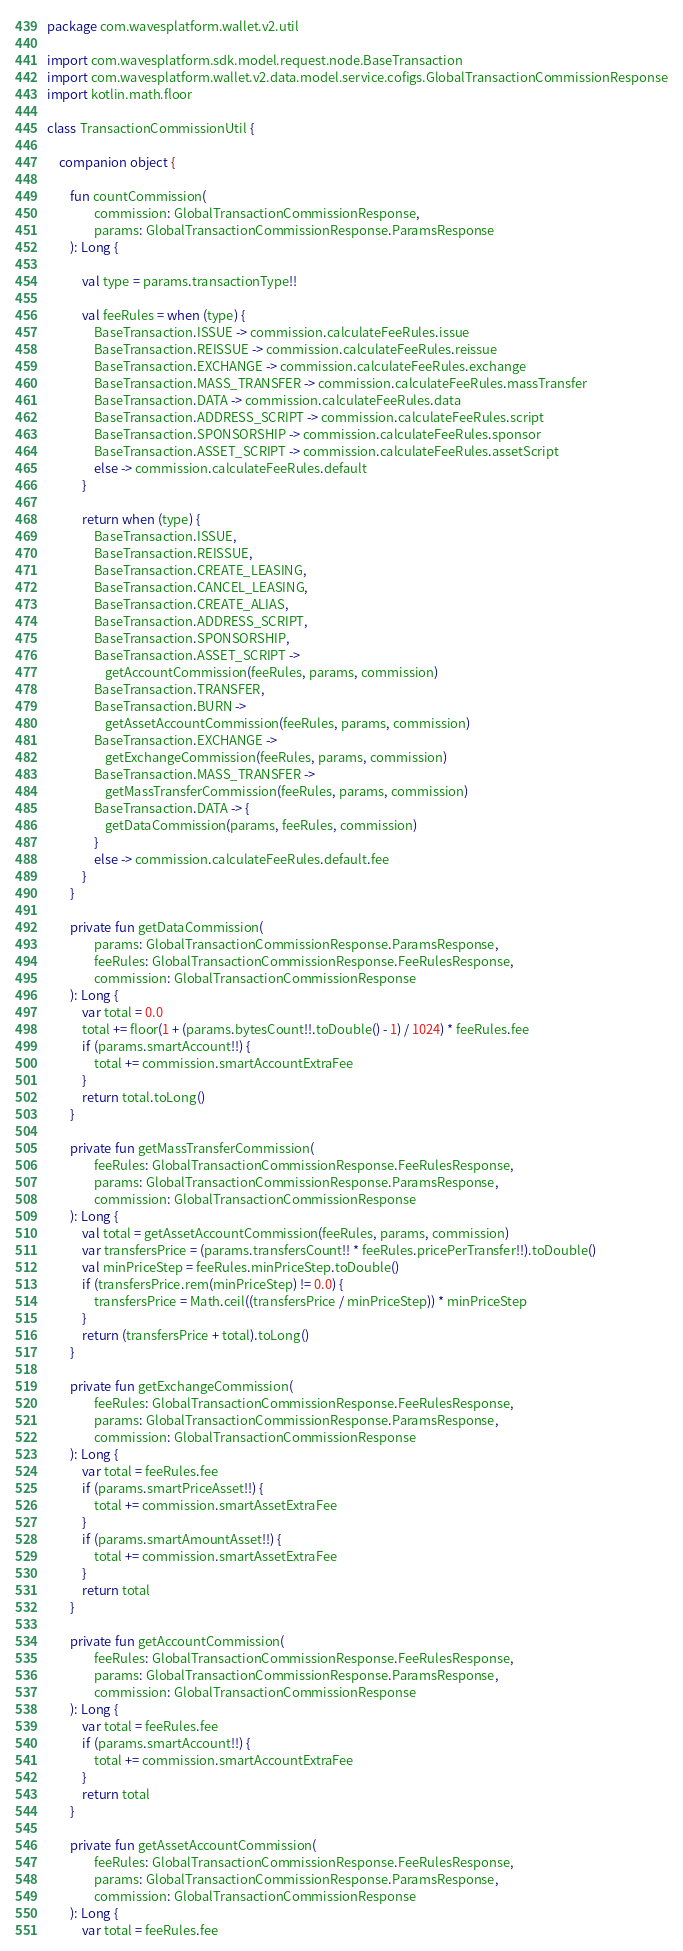<code> <loc_0><loc_0><loc_500><loc_500><_Kotlin_>package com.wavesplatform.wallet.v2.util

import com.wavesplatform.sdk.model.request.node.BaseTransaction
import com.wavesplatform.wallet.v2.data.model.service.cofigs.GlobalTransactionCommissionResponse
import kotlin.math.floor

class TransactionCommissionUtil {

    companion object {

        fun countCommission(
                commission: GlobalTransactionCommissionResponse,
                params: GlobalTransactionCommissionResponse.ParamsResponse
        ): Long {

            val type = params.transactionType!!

            val feeRules = when (type) {
                BaseTransaction.ISSUE -> commission.calculateFeeRules.issue
                BaseTransaction.REISSUE -> commission.calculateFeeRules.reissue
                BaseTransaction.EXCHANGE -> commission.calculateFeeRules.exchange
                BaseTransaction.MASS_TRANSFER -> commission.calculateFeeRules.massTransfer
                BaseTransaction.DATA -> commission.calculateFeeRules.data
                BaseTransaction.ADDRESS_SCRIPT -> commission.calculateFeeRules.script
                BaseTransaction.SPONSORSHIP -> commission.calculateFeeRules.sponsor
                BaseTransaction.ASSET_SCRIPT -> commission.calculateFeeRules.assetScript
                else -> commission.calculateFeeRules.default
            }

            return when (type) {
                BaseTransaction.ISSUE,
                BaseTransaction.REISSUE,
                BaseTransaction.CREATE_LEASING,
                BaseTransaction.CANCEL_LEASING,
                BaseTransaction.CREATE_ALIAS,
                BaseTransaction.ADDRESS_SCRIPT,
                BaseTransaction.SPONSORSHIP,
                BaseTransaction.ASSET_SCRIPT ->
                    getAccountCommission(feeRules, params, commission)
                BaseTransaction.TRANSFER,
                BaseTransaction.BURN ->
                    getAssetAccountCommission(feeRules, params, commission)
                BaseTransaction.EXCHANGE ->
                    getExchangeCommission(feeRules, params, commission)
                BaseTransaction.MASS_TRANSFER ->
                    getMassTransferCommission(feeRules, params, commission)
                BaseTransaction.DATA -> {
                    getDataCommission(params, feeRules, commission)
                }
                else -> commission.calculateFeeRules.default.fee
            }
        }

        private fun getDataCommission(
                params: GlobalTransactionCommissionResponse.ParamsResponse,
                feeRules: GlobalTransactionCommissionResponse.FeeRulesResponse,
                commission: GlobalTransactionCommissionResponse
        ): Long {
            var total = 0.0
            total += floor(1 + (params.bytesCount!!.toDouble() - 1) / 1024) * feeRules.fee
            if (params.smartAccount!!) {
                total += commission.smartAccountExtraFee
            }
            return total.toLong()
        }

        private fun getMassTransferCommission(
                feeRules: GlobalTransactionCommissionResponse.FeeRulesResponse,
                params: GlobalTransactionCommissionResponse.ParamsResponse,
                commission: GlobalTransactionCommissionResponse
        ): Long {
            val total = getAssetAccountCommission(feeRules, params, commission)
            var transfersPrice = (params.transfersCount!! * feeRules.pricePerTransfer!!).toDouble()
            val minPriceStep = feeRules.minPriceStep.toDouble()
            if (transfersPrice.rem(minPriceStep) != 0.0) {
                transfersPrice = Math.ceil((transfersPrice / minPriceStep)) * minPriceStep
            }
            return (transfersPrice + total).toLong()
        }

        private fun getExchangeCommission(
                feeRules: GlobalTransactionCommissionResponse.FeeRulesResponse,
                params: GlobalTransactionCommissionResponse.ParamsResponse,
                commission: GlobalTransactionCommissionResponse
        ): Long {
            var total = feeRules.fee
            if (params.smartPriceAsset!!) {
                total += commission.smartAssetExtraFee
            }
            if (params.smartAmountAsset!!) {
                total += commission.smartAssetExtraFee
            }
            return total
        }

        private fun getAccountCommission(
                feeRules: GlobalTransactionCommissionResponse.FeeRulesResponse,
                params: GlobalTransactionCommissionResponse.ParamsResponse,
                commission: GlobalTransactionCommissionResponse
        ): Long {
            var total = feeRules.fee
            if (params.smartAccount!!) {
                total += commission.smartAccountExtraFee
            }
            return total
        }

        private fun getAssetAccountCommission(
                feeRules: GlobalTransactionCommissionResponse.FeeRulesResponse,
                params: GlobalTransactionCommissionResponse.ParamsResponse,
                commission: GlobalTransactionCommissionResponse
        ): Long {
            var total = feeRules.fee</code> 